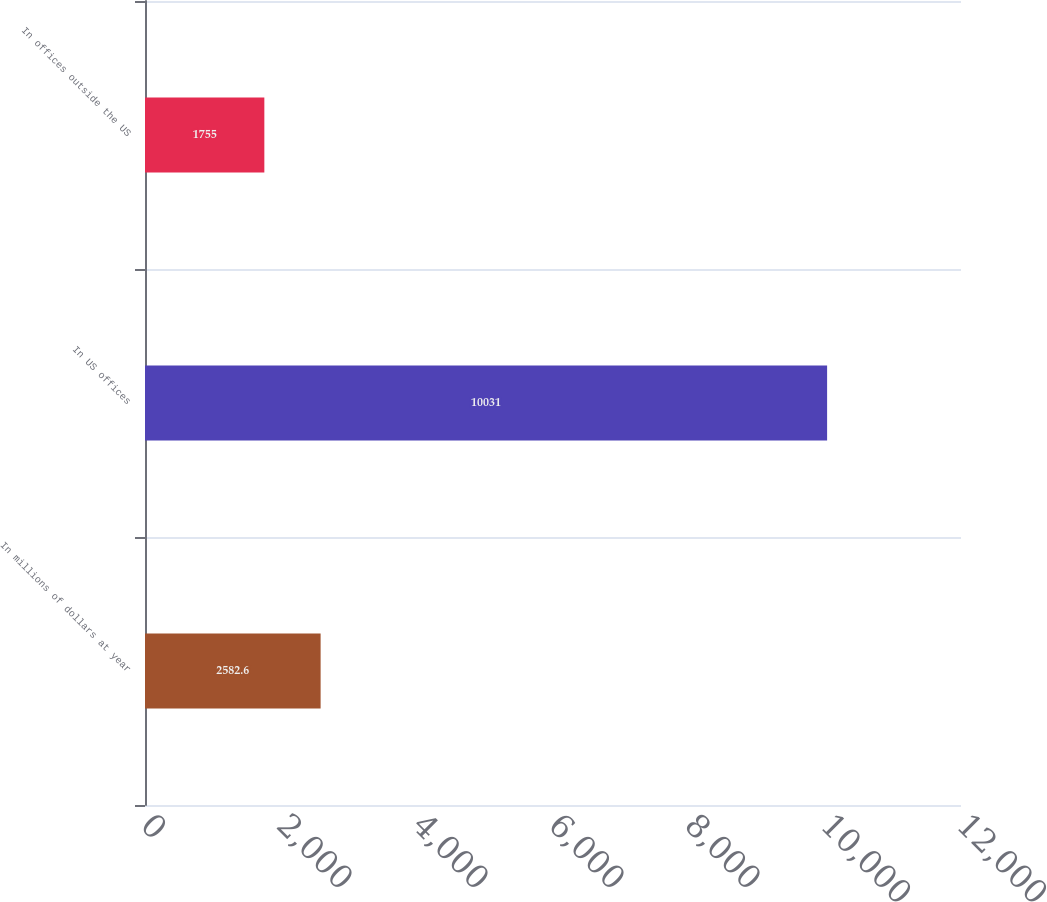<chart> <loc_0><loc_0><loc_500><loc_500><bar_chart><fcel>In millions of dollars at year<fcel>In US offices<fcel>In offices outside the US<nl><fcel>2582.6<fcel>10031<fcel>1755<nl></chart> 